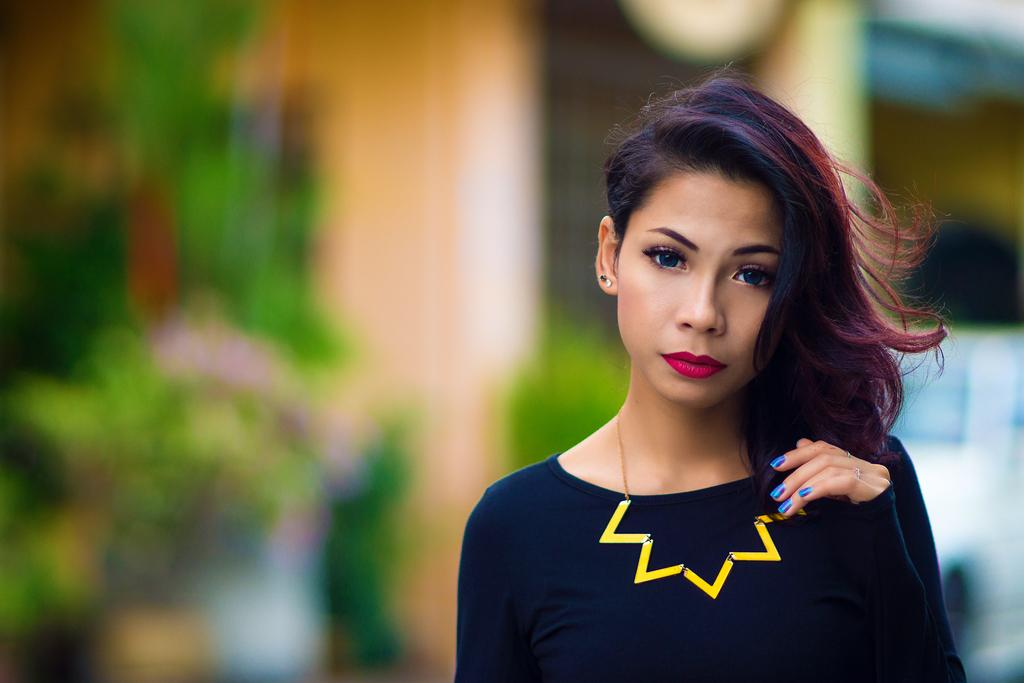What is the main subject of the image? There is a person in the image. What is the person wearing in the image? The person is wearing a navy blue color dress and a yellow color neck chain. What color is the background of the image? The background of the image is black. What type of store can be seen in the background of the image? There is no store visible in the image; the background is black. How many wishes does the person in the image have? There is no information about the person's wishes in the image. 